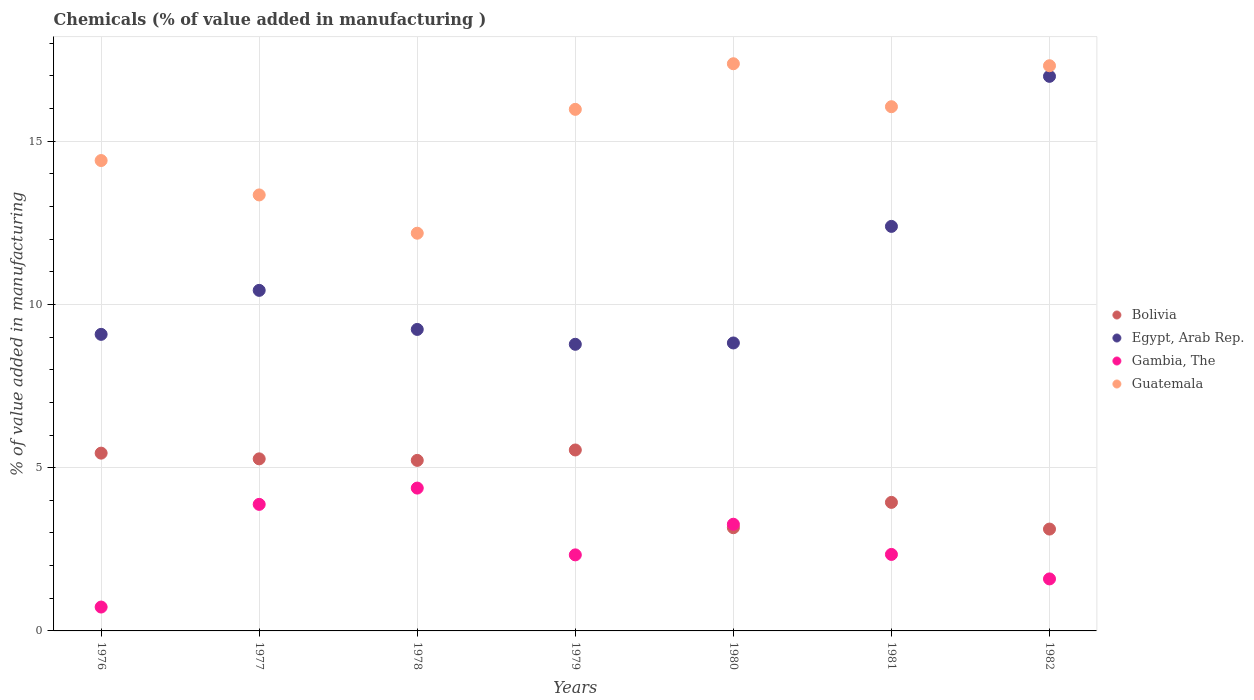Is the number of dotlines equal to the number of legend labels?
Your answer should be very brief. Yes. What is the value added in manufacturing chemicals in Bolivia in 1980?
Ensure brevity in your answer.  3.16. Across all years, what is the maximum value added in manufacturing chemicals in Gambia, The?
Offer a terse response. 4.38. Across all years, what is the minimum value added in manufacturing chemicals in Bolivia?
Your answer should be very brief. 3.12. In which year was the value added in manufacturing chemicals in Egypt, Arab Rep. minimum?
Ensure brevity in your answer.  1979. What is the total value added in manufacturing chemicals in Egypt, Arab Rep. in the graph?
Give a very brief answer. 75.73. What is the difference between the value added in manufacturing chemicals in Egypt, Arab Rep. in 1976 and that in 1982?
Provide a succinct answer. -7.9. What is the difference between the value added in manufacturing chemicals in Guatemala in 1976 and the value added in manufacturing chemicals in Bolivia in 1982?
Offer a very short reply. 11.29. What is the average value added in manufacturing chemicals in Gambia, The per year?
Offer a very short reply. 2.65. In the year 1979, what is the difference between the value added in manufacturing chemicals in Guatemala and value added in manufacturing chemicals in Bolivia?
Offer a very short reply. 10.43. In how many years, is the value added in manufacturing chemicals in Egypt, Arab Rep. greater than 6 %?
Offer a very short reply. 7. What is the ratio of the value added in manufacturing chemicals in Guatemala in 1979 to that in 1980?
Provide a succinct answer. 0.92. Is the value added in manufacturing chemicals in Guatemala in 1979 less than that in 1982?
Offer a terse response. Yes. What is the difference between the highest and the second highest value added in manufacturing chemicals in Guatemala?
Give a very brief answer. 0.06. What is the difference between the highest and the lowest value added in manufacturing chemicals in Bolivia?
Ensure brevity in your answer.  2.42. In how many years, is the value added in manufacturing chemicals in Egypt, Arab Rep. greater than the average value added in manufacturing chemicals in Egypt, Arab Rep. taken over all years?
Ensure brevity in your answer.  2. Is it the case that in every year, the sum of the value added in manufacturing chemicals in Guatemala and value added in manufacturing chemicals in Egypt, Arab Rep.  is greater than the sum of value added in manufacturing chemicals in Bolivia and value added in manufacturing chemicals in Gambia, The?
Give a very brief answer. Yes. Is it the case that in every year, the sum of the value added in manufacturing chemicals in Guatemala and value added in manufacturing chemicals in Bolivia  is greater than the value added in manufacturing chemicals in Gambia, The?
Provide a succinct answer. Yes. Does the value added in manufacturing chemicals in Bolivia monotonically increase over the years?
Your answer should be compact. No. Is the value added in manufacturing chemicals in Egypt, Arab Rep. strictly greater than the value added in manufacturing chemicals in Bolivia over the years?
Provide a succinct answer. Yes. Is the value added in manufacturing chemicals in Guatemala strictly less than the value added in manufacturing chemicals in Gambia, The over the years?
Ensure brevity in your answer.  No. How many years are there in the graph?
Your response must be concise. 7. What is the difference between two consecutive major ticks on the Y-axis?
Your answer should be compact. 5. Does the graph contain grids?
Offer a very short reply. Yes. How many legend labels are there?
Your response must be concise. 4. How are the legend labels stacked?
Give a very brief answer. Vertical. What is the title of the graph?
Make the answer very short. Chemicals (% of value added in manufacturing ). Does "Cyprus" appear as one of the legend labels in the graph?
Keep it short and to the point. No. What is the label or title of the X-axis?
Offer a terse response. Years. What is the label or title of the Y-axis?
Give a very brief answer. % of value added in manufacturing. What is the % of value added in manufacturing in Bolivia in 1976?
Your answer should be very brief. 5.45. What is the % of value added in manufacturing of Egypt, Arab Rep. in 1976?
Keep it short and to the point. 9.08. What is the % of value added in manufacturing in Gambia, The in 1976?
Your answer should be very brief. 0.73. What is the % of value added in manufacturing in Guatemala in 1976?
Make the answer very short. 14.41. What is the % of value added in manufacturing of Bolivia in 1977?
Provide a short and direct response. 5.27. What is the % of value added in manufacturing of Egypt, Arab Rep. in 1977?
Your answer should be compact. 10.43. What is the % of value added in manufacturing of Gambia, The in 1977?
Your response must be concise. 3.88. What is the % of value added in manufacturing of Guatemala in 1977?
Provide a succinct answer. 13.36. What is the % of value added in manufacturing of Bolivia in 1978?
Keep it short and to the point. 5.22. What is the % of value added in manufacturing in Egypt, Arab Rep. in 1978?
Provide a succinct answer. 9.24. What is the % of value added in manufacturing in Gambia, The in 1978?
Provide a short and direct response. 4.38. What is the % of value added in manufacturing of Guatemala in 1978?
Your response must be concise. 12.18. What is the % of value added in manufacturing in Bolivia in 1979?
Make the answer very short. 5.54. What is the % of value added in manufacturing in Egypt, Arab Rep. in 1979?
Ensure brevity in your answer.  8.78. What is the % of value added in manufacturing of Gambia, The in 1979?
Ensure brevity in your answer.  2.33. What is the % of value added in manufacturing in Guatemala in 1979?
Offer a very short reply. 15.98. What is the % of value added in manufacturing in Bolivia in 1980?
Your response must be concise. 3.16. What is the % of value added in manufacturing of Egypt, Arab Rep. in 1980?
Provide a short and direct response. 8.82. What is the % of value added in manufacturing in Gambia, The in 1980?
Provide a succinct answer. 3.27. What is the % of value added in manufacturing in Guatemala in 1980?
Make the answer very short. 17.37. What is the % of value added in manufacturing in Bolivia in 1981?
Make the answer very short. 3.94. What is the % of value added in manufacturing in Egypt, Arab Rep. in 1981?
Provide a short and direct response. 12.39. What is the % of value added in manufacturing of Gambia, The in 1981?
Your answer should be very brief. 2.34. What is the % of value added in manufacturing in Guatemala in 1981?
Provide a succinct answer. 16.06. What is the % of value added in manufacturing in Bolivia in 1982?
Your response must be concise. 3.12. What is the % of value added in manufacturing of Egypt, Arab Rep. in 1982?
Your response must be concise. 16.99. What is the % of value added in manufacturing in Gambia, The in 1982?
Make the answer very short. 1.59. What is the % of value added in manufacturing of Guatemala in 1982?
Keep it short and to the point. 17.31. Across all years, what is the maximum % of value added in manufacturing of Bolivia?
Your answer should be very brief. 5.54. Across all years, what is the maximum % of value added in manufacturing of Egypt, Arab Rep.?
Ensure brevity in your answer.  16.99. Across all years, what is the maximum % of value added in manufacturing in Gambia, The?
Offer a very short reply. 4.38. Across all years, what is the maximum % of value added in manufacturing of Guatemala?
Keep it short and to the point. 17.37. Across all years, what is the minimum % of value added in manufacturing of Bolivia?
Provide a succinct answer. 3.12. Across all years, what is the minimum % of value added in manufacturing in Egypt, Arab Rep.?
Provide a succinct answer. 8.78. Across all years, what is the minimum % of value added in manufacturing in Gambia, The?
Provide a succinct answer. 0.73. Across all years, what is the minimum % of value added in manufacturing of Guatemala?
Make the answer very short. 12.18. What is the total % of value added in manufacturing in Bolivia in the graph?
Your answer should be very brief. 31.7. What is the total % of value added in manufacturing of Egypt, Arab Rep. in the graph?
Your answer should be compact. 75.73. What is the total % of value added in manufacturing in Gambia, The in the graph?
Your answer should be compact. 18.52. What is the total % of value added in manufacturing of Guatemala in the graph?
Your answer should be compact. 106.67. What is the difference between the % of value added in manufacturing in Bolivia in 1976 and that in 1977?
Keep it short and to the point. 0.17. What is the difference between the % of value added in manufacturing in Egypt, Arab Rep. in 1976 and that in 1977?
Your answer should be compact. -1.35. What is the difference between the % of value added in manufacturing in Gambia, The in 1976 and that in 1977?
Your answer should be very brief. -3.15. What is the difference between the % of value added in manufacturing in Guatemala in 1976 and that in 1977?
Give a very brief answer. 1.05. What is the difference between the % of value added in manufacturing in Bolivia in 1976 and that in 1978?
Make the answer very short. 0.22. What is the difference between the % of value added in manufacturing in Egypt, Arab Rep. in 1976 and that in 1978?
Your answer should be very brief. -0.15. What is the difference between the % of value added in manufacturing in Gambia, The in 1976 and that in 1978?
Offer a very short reply. -3.64. What is the difference between the % of value added in manufacturing of Guatemala in 1976 and that in 1978?
Offer a very short reply. 2.23. What is the difference between the % of value added in manufacturing of Bolivia in 1976 and that in 1979?
Ensure brevity in your answer.  -0.1. What is the difference between the % of value added in manufacturing in Egypt, Arab Rep. in 1976 and that in 1979?
Provide a succinct answer. 0.3. What is the difference between the % of value added in manufacturing in Gambia, The in 1976 and that in 1979?
Provide a succinct answer. -1.6. What is the difference between the % of value added in manufacturing in Guatemala in 1976 and that in 1979?
Provide a succinct answer. -1.57. What is the difference between the % of value added in manufacturing in Bolivia in 1976 and that in 1980?
Provide a succinct answer. 2.28. What is the difference between the % of value added in manufacturing of Egypt, Arab Rep. in 1976 and that in 1980?
Your response must be concise. 0.26. What is the difference between the % of value added in manufacturing of Gambia, The in 1976 and that in 1980?
Your answer should be compact. -2.54. What is the difference between the % of value added in manufacturing in Guatemala in 1976 and that in 1980?
Ensure brevity in your answer.  -2.97. What is the difference between the % of value added in manufacturing of Bolivia in 1976 and that in 1981?
Keep it short and to the point. 1.51. What is the difference between the % of value added in manufacturing of Egypt, Arab Rep. in 1976 and that in 1981?
Provide a succinct answer. -3.31. What is the difference between the % of value added in manufacturing in Gambia, The in 1976 and that in 1981?
Provide a succinct answer. -1.61. What is the difference between the % of value added in manufacturing of Guatemala in 1976 and that in 1981?
Make the answer very short. -1.65. What is the difference between the % of value added in manufacturing in Bolivia in 1976 and that in 1982?
Offer a very short reply. 2.33. What is the difference between the % of value added in manufacturing of Egypt, Arab Rep. in 1976 and that in 1982?
Your response must be concise. -7.9. What is the difference between the % of value added in manufacturing of Gambia, The in 1976 and that in 1982?
Make the answer very short. -0.86. What is the difference between the % of value added in manufacturing of Guatemala in 1976 and that in 1982?
Offer a terse response. -2.9. What is the difference between the % of value added in manufacturing in Bolivia in 1977 and that in 1978?
Your answer should be very brief. 0.05. What is the difference between the % of value added in manufacturing of Egypt, Arab Rep. in 1977 and that in 1978?
Provide a succinct answer. 1.2. What is the difference between the % of value added in manufacturing in Gambia, The in 1977 and that in 1978?
Your answer should be compact. -0.5. What is the difference between the % of value added in manufacturing of Guatemala in 1977 and that in 1978?
Offer a very short reply. 1.17. What is the difference between the % of value added in manufacturing in Bolivia in 1977 and that in 1979?
Your answer should be compact. -0.27. What is the difference between the % of value added in manufacturing of Egypt, Arab Rep. in 1977 and that in 1979?
Offer a very short reply. 1.65. What is the difference between the % of value added in manufacturing of Gambia, The in 1977 and that in 1979?
Keep it short and to the point. 1.55. What is the difference between the % of value added in manufacturing in Guatemala in 1977 and that in 1979?
Give a very brief answer. -2.62. What is the difference between the % of value added in manufacturing in Bolivia in 1977 and that in 1980?
Provide a short and direct response. 2.11. What is the difference between the % of value added in manufacturing in Egypt, Arab Rep. in 1977 and that in 1980?
Give a very brief answer. 1.61. What is the difference between the % of value added in manufacturing in Gambia, The in 1977 and that in 1980?
Provide a short and direct response. 0.61. What is the difference between the % of value added in manufacturing of Guatemala in 1977 and that in 1980?
Offer a terse response. -4.02. What is the difference between the % of value added in manufacturing of Bolivia in 1977 and that in 1981?
Offer a very short reply. 1.33. What is the difference between the % of value added in manufacturing in Egypt, Arab Rep. in 1977 and that in 1981?
Ensure brevity in your answer.  -1.96. What is the difference between the % of value added in manufacturing in Gambia, The in 1977 and that in 1981?
Your answer should be compact. 1.53. What is the difference between the % of value added in manufacturing in Guatemala in 1977 and that in 1981?
Keep it short and to the point. -2.7. What is the difference between the % of value added in manufacturing in Bolivia in 1977 and that in 1982?
Your response must be concise. 2.15. What is the difference between the % of value added in manufacturing of Egypt, Arab Rep. in 1977 and that in 1982?
Provide a short and direct response. -6.56. What is the difference between the % of value added in manufacturing of Gambia, The in 1977 and that in 1982?
Your response must be concise. 2.28. What is the difference between the % of value added in manufacturing of Guatemala in 1977 and that in 1982?
Your response must be concise. -3.96. What is the difference between the % of value added in manufacturing of Bolivia in 1978 and that in 1979?
Provide a short and direct response. -0.32. What is the difference between the % of value added in manufacturing in Egypt, Arab Rep. in 1978 and that in 1979?
Your response must be concise. 0.46. What is the difference between the % of value added in manufacturing in Gambia, The in 1978 and that in 1979?
Make the answer very short. 2.05. What is the difference between the % of value added in manufacturing in Guatemala in 1978 and that in 1979?
Ensure brevity in your answer.  -3.79. What is the difference between the % of value added in manufacturing of Bolivia in 1978 and that in 1980?
Offer a terse response. 2.06. What is the difference between the % of value added in manufacturing of Egypt, Arab Rep. in 1978 and that in 1980?
Make the answer very short. 0.41. What is the difference between the % of value added in manufacturing of Gambia, The in 1978 and that in 1980?
Your response must be concise. 1.11. What is the difference between the % of value added in manufacturing in Guatemala in 1978 and that in 1980?
Provide a succinct answer. -5.19. What is the difference between the % of value added in manufacturing in Bolivia in 1978 and that in 1981?
Offer a terse response. 1.29. What is the difference between the % of value added in manufacturing of Egypt, Arab Rep. in 1978 and that in 1981?
Provide a short and direct response. -3.16. What is the difference between the % of value added in manufacturing of Gambia, The in 1978 and that in 1981?
Ensure brevity in your answer.  2.03. What is the difference between the % of value added in manufacturing of Guatemala in 1978 and that in 1981?
Provide a short and direct response. -3.88. What is the difference between the % of value added in manufacturing of Bolivia in 1978 and that in 1982?
Offer a terse response. 2.1. What is the difference between the % of value added in manufacturing of Egypt, Arab Rep. in 1978 and that in 1982?
Ensure brevity in your answer.  -7.75. What is the difference between the % of value added in manufacturing in Gambia, The in 1978 and that in 1982?
Your answer should be very brief. 2.78. What is the difference between the % of value added in manufacturing in Guatemala in 1978 and that in 1982?
Provide a short and direct response. -5.13. What is the difference between the % of value added in manufacturing in Bolivia in 1979 and that in 1980?
Offer a very short reply. 2.38. What is the difference between the % of value added in manufacturing in Egypt, Arab Rep. in 1979 and that in 1980?
Offer a very short reply. -0.04. What is the difference between the % of value added in manufacturing of Gambia, The in 1979 and that in 1980?
Offer a very short reply. -0.94. What is the difference between the % of value added in manufacturing of Guatemala in 1979 and that in 1980?
Ensure brevity in your answer.  -1.4. What is the difference between the % of value added in manufacturing of Bolivia in 1979 and that in 1981?
Offer a very short reply. 1.61. What is the difference between the % of value added in manufacturing in Egypt, Arab Rep. in 1979 and that in 1981?
Provide a short and direct response. -3.61. What is the difference between the % of value added in manufacturing in Gambia, The in 1979 and that in 1981?
Keep it short and to the point. -0.01. What is the difference between the % of value added in manufacturing of Guatemala in 1979 and that in 1981?
Ensure brevity in your answer.  -0.08. What is the difference between the % of value added in manufacturing in Bolivia in 1979 and that in 1982?
Give a very brief answer. 2.42. What is the difference between the % of value added in manufacturing of Egypt, Arab Rep. in 1979 and that in 1982?
Keep it short and to the point. -8.21. What is the difference between the % of value added in manufacturing of Gambia, The in 1979 and that in 1982?
Offer a terse response. 0.74. What is the difference between the % of value added in manufacturing of Guatemala in 1979 and that in 1982?
Offer a very short reply. -1.34. What is the difference between the % of value added in manufacturing of Bolivia in 1980 and that in 1981?
Your response must be concise. -0.78. What is the difference between the % of value added in manufacturing of Egypt, Arab Rep. in 1980 and that in 1981?
Provide a succinct answer. -3.57. What is the difference between the % of value added in manufacturing of Gambia, The in 1980 and that in 1981?
Offer a very short reply. 0.92. What is the difference between the % of value added in manufacturing in Guatemala in 1980 and that in 1981?
Ensure brevity in your answer.  1.32. What is the difference between the % of value added in manufacturing in Bolivia in 1980 and that in 1982?
Your answer should be very brief. 0.04. What is the difference between the % of value added in manufacturing of Egypt, Arab Rep. in 1980 and that in 1982?
Keep it short and to the point. -8.17. What is the difference between the % of value added in manufacturing of Gambia, The in 1980 and that in 1982?
Your answer should be compact. 1.67. What is the difference between the % of value added in manufacturing of Guatemala in 1980 and that in 1982?
Provide a succinct answer. 0.06. What is the difference between the % of value added in manufacturing of Bolivia in 1981 and that in 1982?
Offer a terse response. 0.82. What is the difference between the % of value added in manufacturing of Egypt, Arab Rep. in 1981 and that in 1982?
Make the answer very short. -4.6. What is the difference between the % of value added in manufacturing in Guatemala in 1981 and that in 1982?
Give a very brief answer. -1.25. What is the difference between the % of value added in manufacturing of Bolivia in 1976 and the % of value added in manufacturing of Egypt, Arab Rep. in 1977?
Make the answer very short. -4.99. What is the difference between the % of value added in manufacturing of Bolivia in 1976 and the % of value added in manufacturing of Gambia, The in 1977?
Offer a very short reply. 1.57. What is the difference between the % of value added in manufacturing in Bolivia in 1976 and the % of value added in manufacturing in Guatemala in 1977?
Make the answer very short. -7.91. What is the difference between the % of value added in manufacturing in Egypt, Arab Rep. in 1976 and the % of value added in manufacturing in Gambia, The in 1977?
Keep it short and to the point. 5.21. What is the difference between the % of value added in manufacturing in Egypt, Arab Rep. in 1976 and the % of value added in manufacturing in Guatemala in 1977?
Offer a terse response. -4.27. What is the difference between the % of value added in manufacturing of Gambia, The in 1976 and the % of value added in manufacturing of Guatemala in 1977?
Ensure brevity in your answer.  -12.62. What is the difference between the % of value added in manufacturing of Bolivia in 1976 and the % of value added in manufacturing of Egypt, Arab Rep. in 1978?
Offer a terse response. -3.79. What is the difference between the % of value added in manufacturing of Bolivia in 1976 and the % of value added in manufacturing of Gambia, The in 1978?
Your answer should be compact. 1.07. What is the difference between the % of value added in manufacturing in Bolivia in 1976 and the % of value added in manufacturing in Guatemala in 1978?
Keep it short and to the point. -6.74. What is the difference between the % of value added in manufacturing of Egypt, Arab Rep. in 1976 and the % of value added in manufacturing of Gambia, The in 1978?
Provide a short and direct response. 4.71. What is the difference between the % of value added in manufacturing of Egypt, Arab Rep. in 1976 and the % of value added in manufacturing of Guatemala in 1978?
Provide a succinct answer. -3.1. What is the difference between the % of value added in manufacturing in Gambia, The in 1976 and the % of value added in manufacturing in Guatemala in 1978?
Your answer should be compact. -11.45. What is the difference between the % of value added in manufacturing in Bolivia in 1976 and the % of value added in manufacturing in Egypt, Arab Rep. in 1979?
Offer a very short reply. -3.33. What is the difference between the % of value added in manufacturing in Bolivia in 1976 and the % of value added in manufacturing in Gambia, The in 1979?
Make the answer very short. 3.12. What is the difference between the % of value added in manufacturing of Bolivia in 1976 and the % of value added in manufacturing of Guatemala in 1979?
Provide a succinct answer. -10.53. What is the difference between the % of value added in manufacturing of Egypt, Arab Rep. in 1976 and the % of value added in manufacturing of Gambia, The in 1979?
Your answer should be compact. 6.75. What is the difference between the % of value added in manufacturing of Egypt, Arab Rep. in 1976 and the % of value added in manufacturing of Guatemala in 1979?
Give a very brief answer. -6.89. What is the difference between the % of value added in manufacturing in Gambia, The in 1976 and the % of value added in manufacturing in Guatemala in 1979?
Your response must be concise. -15.25. What is the difference between the % of value added in manufacturing of Bolivia in 1976 and the % of value added in manufacturing of Egypt, Arab Rep. in 1980?
Offer a very short reply. -3.38. What is the difference between the % of value added in manufacturing of Bolivia in 1976 and the % of value added in manufacturing of Gambia, The in 1980?
Provide a succinct answer. 2.18. What is the difference between the % of value added in manufacturing of Bolivia in 1976 and the % of value added in manufacturing of Guatemala in 1980?
Provide a short and direct response. -11.93. What is the difference between the % of value added in manufacturing of Egypt, Arab Rep. in 1976 and the % of value added in manufacturing of Gambia, The in 1980?
Your answer should be compact. 5.82. What is the difference between the % of value added in manufacturing of Egypt, Arab Rep. in 1976 and the % of value added in manufacturing of Guatemala in 1980?
Ensure brevity in your answer.  -8.29. What is the difference between the % of value added in manufacturing of Gambia, The in 1976 and the % of value added in manufacturing of Guatemala in 1980?
Your answer should be compact. -16.64. What is the difference between the % of value added in manufacturing of Bolivia in 1976 and the % of value added in manufacturing of Egypt, Arab Rep. in 1981?
Provide a short and direct response. -6.95. What is the difference between the % of value added in manufacturing of Bolivia in 1976 and the % of value added in manufacturing of Gambia, The in 1981?
Your response must be concise. 3.1. What is the difference between the % of value added in manufacturing of Bolivia in 1976 and the % of value added in manufacturing of Guatemala in 1981?
Keep it short and to the point. -10.61. What is the difference between the % of value added in manufacturing in Egypt, Arab Rep. in 1976 and the % of value added in manufacturing in Gambia, The in 1981?
Provide a succinct answer. 6.74. What is the difference between the % of value added in manufacturing of Egypt, Arab Rep. in 1976 and the % of value added in manufacturing of Guatemala in 1981?
Offer a very short reply. -6.97. What is the difference between the % of value added in manufacturing of Gambia, The in 1976 and the % of value added in manufacturing of Guatemala in 1981?
Ensure brevity in your answer.  -15.33. What is the difference between the % of value added in manufacturing in Bolivia in 1976 and the % of value added in manufacturing in Egypt, Arab Rep. in 1982?
Provide a short and direct response. -11.54. What is the difference between the % of value added in manufacturing in Bolivia in 1976 and the % of value added in manufacturing in Gambia, The in 1982?
Keep it short and to the point. 3.85. What is the difference between the % of value added in manufacturing of Bolivia in 1976 and the % of value added in manufacturing of Guatemala in 1982?
Your answer should be compact. -11.87. What is the difference between the % of value added in manufacturing in Egypt, Arab Rep. in 1976 and the % of value added in manufacturing in Gambia, The in 1982?
Give a very brief answer. 7.49. What is the difference between the % of value added in manufacturing in Egypt, Arab Rep. in 1976 and the % of value added in manufacturing in Guatemala in 1982?
Make the answer very short. -8.23. What is the difference between the % of value added in manufacturing in Gambia, The in 1976 and the % of value added in manufacturing in Guatemala in 1982?
Keep it short and to the point. -16.58. What is the difference between the % of value added in manufacturing of Bolivia in 1977 and the % of value added in manufacturing of Egypt, Arab Rep. in 1978?
Ensure brevity in your answer.  -3.96. What is the difference between the % of value added in manufacturing in Bolivia in 1977 and the % of value added in manufacturing in Gambia, The in 1978?
Keep it short and to the point. 0.9. What is the difference between the % of value added in manufacturing of Bolivia in 1977 and the % of value added in manufacturing of Guatemala in 1978?
Make the answer very short. -6.91. What is the difference between the % of value added in manufacturing in Egypt, Arab Rep. in 1977 and the % of value added in manufacturing in Gambia, The in 1978?
Provide a short and direct response. 6.06. What is the difference between the % of value added in manufacturing of Egypt, Arab Rep. in 1977 and the % of value added in manufacturing of Guatemala in 1978?
Offer a terse response. -1.75. What is the difference between the % of value added in manufacturing of Gambia, The in 1977 and the % of value added in manufacturing of Guatemala in 1978?
Provide a short and direct response. -8.31. What is the difference between the % of value added in manufacturing of Bolivia in 1977 and the % of value added in manufacturing of Egypt, Arab Rep. in 1979?
Your answer should be compact. -3.51. What is the difference between the % of value added in manufacturing of Bolivia in 1977 and the % of value added in manufacturing of Gambia, The in 1979?
Your answer should be very brief. 2.94. What is the difference between the % of value added in manufacturing in Bolivia in 1977 and the % of value added in manufacturing in Guatemala in 1979?
Make the answer very short. -10.71. What is the difference between the % of value added in manufacturing in Egypt, Arab Rep. in 1977 and the % of value added in manufacturing in Gambia, The in 1979?
Offer a very short reply. 8.1. What is the difference between the % of value added in manufacturing of Egypt, Arab Rep. in 1977 and the % of value added in manufacturing of Guatemala in 1979?
Provide a succinct answer. -5.54. What is the difference between the % of value added in manufacturing of Gambia, The in 1977 and the % of value added in manufacturing of Guatemala in 1979?
Keep it short and to the point. -12.1. What is the difference between the % of value added in manufacturing in Bolivia in 1977 and the % of value added in manufacturing in Egypt, Arab Rep. in 1980?
Make the answer very short. -3.55. What is the difference between the % of value added in manufacturing of Bolivia in 1977 and the % of value added in manufacturing of Gambia, The in 1980?
Give a very brief answer. 2. What is the difference between the % of value added in manufacturing of Bolivia in 1977 and the % of value added in manufacturing of Guatemala in 1980?
Give a very brief answer. -12.1. What is the difference between the % of value added in manufacturing in Egypt, Arab Rep. in 1977 and the % of value added in manufacturing in Gambia, The in 1980?
Ensure brevity in your answer.  7.16. What is the difference between the % of value added in manufacturing of Egypt, Arab Rep. in 1977 and the % of value added in manufacturing of Guatemala in 1980?
Ensure brevity in your answer.  -6.94. What is the difference between the % of value added in manufacturing of Gambia, The in 1977 and the % of value added in manufacturing of Guatemala in 1980?
Keep it short and to the point. -13.5. What is the difference between the % of value added in manufacturing of Bolivia in 1977 and the % of value added in manufacturing of Egypt, Arab Rep. in 1981?
Offer a terse response. -7.12. What is the difference between the % of value added in manufacturing in Bolivia in 1977 and the % of value added in manufacturing in Gambia, The in 1981?
Offer a very short reply. 2.93. What is the difference between the % of value added in manufacturing in Bolivia in 1977 and the % of value added in manufacturing in Guatemala in 1981?
Ensure brevity in your answer.  -10.79. What is the difference between the % of value added in manufacturing of Egypt, Arab Rep. in 1977 and the % of value added in manufacturing of Gambia, The in 1981?
Your answer should be compact. 8.09. What is the difference between the % of value added in manufacturing of Egypt, Arab Rep. in 1977 and the % of value added in manufacturing of Guatemala in 1981?
Your answer should be very brief. -5.63. What is the difference between the % of value added in manufacturing of Gambia, The in 1977 and the % of value added in manufacturing of Guatemala in 1981?
Offer a terse response. -12.18. What is the difference between the % of value added in manufacturing of Bolivia in 1977 and the % of value added in manufacturing of Egypt, Arab Rep. in 1982?
Offer a very short reply. -11.72. What is the difference between the % of value added in manufacturing in Bolivia in 1977 and the % of value added in manufacturing in Gambia, The in 1982?
Your answer should be very brief. 3.68. What is the difference between the % of value added in manufacturing of Bolivia in 1977 and the % of value added in manufacturing of Guatemala in 1982?
Offer a terse response. -12.04. What is the difference between the % of value added in manufacturing in Egypt, Arab Rep. in 1977 and the % of value added in manufacturing in Gambia, The in 1982?
Offer a very short reply. 8.84. What is the difference between the % of value added in manufacturing of Egypt, Arab Rep. in 1977 and the % of value added in manufacturing of Guatemala in 1982?
Your response must be concise. -6.88. What is the difference between the % of value added in manufacturing of Gambia, The in 1977 and the % of value added in manufacturing of Guatemala in 1982?
Provide a succinct answer. -13.44. What is the difference between the % of value added in manufacturing in Bolivia in 1978 and the % of value added in manufacturing in Egypt, Arab Rep. in 1979?
Provide a short and direct response. -3.56. What is the difference between the % of value added in manufacturing of Bolivia in 1978 and the % of value added in manufacturing of Gambia, The in 1979?
Provide a succinct answer. 2.89. What is the difference between the % of value added in manufacturing in Bolivia in 1978 and the % of value added in manufacturing in Guatemala in 1979?
Provide a succinct answer. -10.75. What is the difference between the % of value added in manufacturing of Egypt, Arab Rep. in 1978 and the % of value added in manufacturing of Gambia, The in 1979?
Make the answer very short. 6.91. What is the difference between the % of value added in manufacturing of Egypt, Arab Rep. in 1978 and the % of value added in manufacturing of Guatemala in 1979?
Provide a succinct answer. -6.74. What is the difference between the % of value added in manufacturing in Gambia, The in 1978 and the % of value added in manufacturing in Guatemala in 1979?
Make the answer very short. -11.6. What is the difference between the % of value added in manufacturing of Bolivia in 1978 and the % of value added in manufacturing of Egypt, Arab Rep. in 1980?
Your answer should be very brief. -3.6. What is the difference between the % of value added in manufacturing of Bolivia in 1978 and the % of value added in manufacturing of Gambia, The in 1980?
Give a very brief answer. 1.96. What is the difference between the % of value added in manufacturing in Bolivia in 1978 and the % of value added in manufacturing in Guatemala in 1980?
Your response must be concise. -12.15. What is the difference between the % of value added in manufacturing in Egypt, Arab Rep. in 1978 and the % of value added in manufacturing in Gambia, The in 1980?
Provide a succinct answer. 5.97. What is the difference between the % of value added in manufacturing in Egypt, Arab Rep. in 1978 and the % of value added in manufacturing in Guatemala in 1980?
Give a very brief answer. -8.14. What is the difference between the % of value added in manufacturing of Gambia, The in 1978 and the % of value added in manufacturing of Guatemala in 1980?
Offer a very short reply. -13. What is the difference between the % of value added in manufacturing in Bolivia in 1978 and the % of value added in manufacturing in Egypt, Arab Rep. in 1981?
Keep it short and to the point. -7.17. What is the difference between the % of value added in manufacturing in Bolivia in 1978 and the % of value added in manufacturing in Gambia, The in 1981?
Offer a very short reply. 2.88. What is the difference between the % of value added in manufacturing of Bolivia in 1978 and the % of value added in manufacturing of Guatemala in 1981?
Give a very brief answer. -10.83. What is the difference between the % of value added in manufacturing of Egypt, Arab Rep. in 1978 and the % of value added in manufacturing of Gambia, The in 1981?
Offer a very short reply. 6.89. What is the difference between the % of value added in manufacturing of Egypt, Arab Rep. in 1978 and the % of value added in manufacturing of Guatemala in 1981?
Offer a very short reply. -6.82. What is the difference between the % of value added in manufacturing in Gambia, The in 1978 and the % of value added in manufacturing in Guatemala in 1981?
Offer a terse response. -11.68. What is the difference between the % of value added in manufacturing in Bolivia in 1978 and the % of value added in manufacturing in Egypt, Arab Rep. in 1982?
Your answer should be compact. -11.76. What is the difference between the % of value added in manufacturing of Bolivia in 1978 and the % of value added in manufacturing of Gambia, The in 1982?
Offer a very short reply. 3.63. What is the difference between the % of value added in manufacturing in Bolivia in 1978 and the % of value added in manufacturing in Guatemala in 1982?
Make the answer very short. -12.09. What is the difference between the % of value added in manufacturing of Egypt, Arab Rep. in 1978 and the % of value added in manufacturing of Gambia, The in 1982?
Ensure brevity in your answer.  7.64. What is the difference between the % of value added in manufacturing of Egypt, Arab Rep. in 1978 and the % of value added in manufacturing of Guatemala in 1982?
Provide a short and direct response. -8.08. What is the difference between the % of value added in manufacturing in Gambia, The in 1978 and the % of value added in manufacturing in Guatemala in 1982?
Your response must be concise. -12.94. What is the difference between the % of value added in manufacturing in Bolivia in 1979 and the % of value added in manufacturing in Egypt, Arab Rep. in 1980?
Your answer should be compact. -3.28. What is the difference between the % of value added in manufacturing of Bolivia in 1979 and the % of value added in manufacturing of Gambia, The in 1980?
Keep it short and to the point. 2.27. What is the difference between the % of value added in manufacturing of Bolivia in 1979 and the % of value added in manufacturing of Guatemala in 1980?
Provide a succinct answer. -11.83. What is the difference between the % of value added in manufacturing of Egypt, Arab Rep. in 1979 and the % of value added in manufacturing of Gambia, The in 1980?
Keep it short and to the point. 5.51. What is the difference between the % of value added in manufacturing of Egypt, Arab Rep. in 1979 and the % of value added in manufacturing of Guatemala in 1980?
Keep it short and to the point. -8.59. What is the difference between the % of value added in manufacturing of Gambia, The in 1979 and the % of value added in manufacturing of Guatemala in 1980?
Offer a terse response. -15.04. What is the difference between the % of value added in manufacturing of Bolivia in 1979 and the % of value added in manufacturing of Egypt, Arab Rep. in 1981?
Provide a succinct answer. -6.85. What is the difference between the % of value added in manufacturing in Bolivia in 1979 and the % of value added in manufacturing in Gambia, The in 1981?
Your answer should be very brief. 3.2. What is the difference between the % of value added in manufacturing in Bolivia in 1979 and the % of value added in manufacturing in Guatemala in 1981?
Your response must be concise. -10.51. What is the difference between the % of value added in manufacturing of Egypt, Arab Rep. in 1979 and the % of value added in manufacturing of Gambia, The in 1981?
Ensure brevity in your answer.  6.44. What is the difference between the % of value added in manufacturing in Egypt, Arab Rep. in 1979 and the % of value added in manufacturing in Guatemala in 1981?
Provide a short and direct response. -7.28. What is the difference between the % of value added in manufacturing of Gambia, The in 1979 and the % of value added in manufacturing of Guatemala in 1981?
Provide a short and direct response. -13.73. What is the difference between the % of value added in manufacturing of Bolivia in 1979 and the % of value added in manufacturing of Egypt, Arab Rep. in 1982?
Your answer should be very brief. -11.45. What is the difference between the % of value added in manufacturing of Bolivia in 1979 and the % of value added in manufacturing of Gambia, The in 1982?
Give a very brief answer. 3.95. What is the difference between the % of value added in manufacturing in Bolivia in 1979 and the % of value added in manufacturing in Guatemala in 1982?
Keep it short and to the point. -11.77. What is the difference between the % of value added in manufacturing in Egypt, Arab Rep. in 1979 and the % of value added in manufacturing in Gambia, The in 1982?
Make the answer very short. 7.19. What is the difference between the % of value added in manufacturing of Egypt, Arab Rep. in 1979 and the % of value added in manufacturing of Guatemala in 1982?
Make the answer very short. -8.53. What is the difference between the % of value added in manufacturing of Gambia, The in 1979 and the % of value added in manufacturing of Guatemala in 1982?
Your answer should be very brief. -14.98. What is the difference between the % of value added in manufacturing in Bolivia in 1980 and the % of value added in manufacturing in Egypt, Arab Rep. in 1981?
Give a very brief answer. -9.23. What is the difference between the % of value added in manufacturing in Bolivia in 1980 and the % of value added in manufacturing in Gambia, The in 1981?
Your response must be concise. 0.82. What is the difference between the % of value added in manufacturing of Bolivia in 1980 and the % of value added in manufacturing of Guatemala in 1981?
Provide a succinct answer. -12.9. What is the difference between the % of value added in manufacturing of Egypt, Arab Rep. in 1980 and the % of value added in manufacturing of Gambia, The in 1981?
Your answer should be very brief. 6.48. What is the difference between the % of value added in manufacturing of Egypt, Arab Rep. in 1980 and the % of value added in manufacturing of Guatemala in 1981?
Make the answer very short. -7.24. What is the difference between the % of value added in manufacturing in Gambia, The in 1980 and the % of value added in manufacturing in Guatemala in 1981?
Make the answer very short. -12.79. What is the difference between the % of value added in manufacturing in Bolivia in 1980 and the % of value added in manufacturing in Egypt, Arab Rep. in 1982?
Make the answer very short. -13.83. What is the difference between the % of value added in manufacturing in Bolivia in 1980 and the % of value added in manufacturing in Gambia, The in 1982?
Offer a terse response. 1.57. What is the difference between the % of value added in manufacturing in Bolivia in 1980 and the % of value added in manufacturing in Guatemala in 1982?
Ensure brevity in your answer.  -14.15. What is the difference between the % of value added in manufacturing of Egypt, Arab Rep. in 1980 and the % of value added in manufacturing of Gambia, The in 1982?
Provide a succinct answer. 7.23. What is the difference between the % of value added in manufacturing of Egypt, Arab Rep. in 1980 and the % of value added in manufacturing of Guatemala in 1982?
Ensure brevity in your answer.  -8.49. What is the difference between the % of value added in manufacturing in Gambia, The in 1980 and the % of value added in manufacturing in Guatemala in 1982?
Offer a very short reply. -14.04. What is the difference between the % of value added in manufacturing in Bolivia in 1981 and the % of value added in manufacturing in Egypt, Arab Rep. in 1982?
Your response must be concise. -13.05. What is the difference between the % of value added in manufacturing of Bolivia in 1981 and the % of value added in manufacturing of Gambia, The in 1982?
Provide a short and direct response. 2.34. What is the difference between the % of value added in manufacturing of Bolivia in 1981 and the % of value added in manufacturing of Guatemala in 1982?
Provide a short and direct response. -13.38. What is the difference between the % of value added in manufacturing of Egypt, Arab Rep. in 1981 and the % of value added in manufacturing of Gambia, The in 1982?
Offer a terse response. 10.8. What is the difference between the % of value added in manufacturing of Egypt, Arab Rep. in 1981 and the % of value added in manufacturing of Guatemala in 1982?
Provide a succinct answer. -4.92. What is the difference between the % of value added in manufacturing of Gambia, The in 1981 and the % of value added in manufacturing of Guatemala in 1982?
Offer a terse response. -14.97. What is the average % of value added in manufacturing of Bolivia per year?
Your answer should be compact. 4.53. What is the average % of value added in manufacturing of Egypt, Arab Rep. per year?
Give a very brief answer. 10.82. What is the average % of value added in manufacturing in Gambia, The per year?
Offer a very short reply. 2.65. What is the average % of value added in manufacturing in Guatemala per year?
Provide a short and direct response. 15.24. In the year 1976, what is the difference between the % of value added in manufacturing in Bolivia and % of value added in manufacturing in Egypt, Arab Rep.?
Offer a terse response. -3.64. In the year 1976, what is the difference between the % of value added in manufacturing in Bolivia and % of value added in manufacturing in Gambia, The?
Your answer should be very brief. 4.71. In the year 1976, what is the difference between the % of value added in manufacturing in Bolivia and % of value added in manufacturing in Guatemala?
Provide a succinct answer. -8.96. In the year 1976, what is the difference between the % of value added in manufacturing in Egypt, Arab Rep. and % of value added in manufacturing in Gambia, The?
Make the answer very short. 8.35. In the year 1976, what is the difference between the % of value added in manufacturing of Egypt, Arab Rep. and % of value added in manufacturing of Guatemala?
Keep it short and to the point. -5.32. In the year 1976, what is the difference between the % of value added in manufacturing in Gambia, The and % of value added in manufacturing in Guatemala?
Offer a very short reply. -13.68. In the year 1977, what is the difference between the % of value added in manufacturing in Bolivia and % of value added in manufacturing in Egypt, Arab Rep.?
Make the answer very short. -5.16. In the year 1977, what is the difference between the % of value added in manufacturing in Bolivia and % of value added in manufacturing in Gambia, The?
Your answer should be compact. 1.39. In the year 1977, what is the difference between the % of value added in manufacturing in Bolivia and % of value added in manufacturing in Guatemala?
Offer a very short reply. -8.08. In the year 1977, what is the difference between the % of value added in manufacturing in Egypt, Arab Rep. and % of value added in manufacturing in Gambia, The?
Your answer should be compact. 6.56. In the year 1977, what is the difference between the % of value added in manufacturing in Egypt, Arab Rep. and % of value added in manufacturing in Guatemala?
Offer a terse response. -2.92. In the year 1977, what is the difference between the % of value added in manufacturing in Gambia, The and % of value added in manufacturing in Guatemala?
Offer a terse response. -9.48. In the year 1978, what is the difference between the % of value added in manufacturing in Bolivia and % of value added in manufacturing in Egypt, Arab Rep.?
Provide a succinct answer. -4.01. In the year 1978, what is the difference between the % of value added in manufacturing in Bolivia and % of value added in manufacturing in Gambia, The?
Make the answer very short. 0.85. In the year 1978, what is the difference between the % of value added in manufacturing of Bolivia and % of value added in manufacturing of Guatemala?
Ensure brevity in your answer.  -6.96. In the year 1978, what is the difference between the % of value added in manufacturing of Egypt, Arab Rep. and % of value added in manufacturing of Gambia, The?
Your answer should be very brief. 4.86. In the year 1978, what is the difference between the % of value added in manufacturing of Egypt, Arab Rep. and % of value added in manufacturing of Guatemala?
Your answer should be very brief. -2.95. In the year 1978, what is the difference between the % of value added in manufacturing in Gambia, The and % of value added in manufacturing in Guatemala?
Provide a short and direct response. -7.81. In the year 1979, what is the difference between the % of value added in manufacturing in Bolivia and % of value added in manufacturing in Egypt, Arab Rep.?
Keep it short and to the point. -3.24. In the year 1979, what is the difference between the % of value added in manufacturing in Bolivia and % of value added in manufacturing in Gambia, The?
Give a very brief answer. 3.21. In the year 1979, what is the difference between the % of value added in manufacturing of Bolivia and % of value added in manufacturing of Guatemala?
Your answer should be compact. -10.43. In the year 1979, what is the difference between the % of value added in manufacturing in Egypt, Arab Rep. and % of value added in manufacturing in Gambia, The?
Your answer should be very brief. 6.45. In the year 1979, what is the difference between the % of value added in manufacturing in Egypt, Arab Rep. and % of value added in manufacturing in Guatemala?
Keep it short and to the point. -7.2. In the year 1979, what is the difference between the % of value added in manufacturing in Gambia, The and % of value added in manufacturing in Guatemala?
Ensure brevity in your answer.  -13.65. In the year 1980, what is the difference between the % of value added in manufacturing in Bolivia and % of value added in manufacturing in Egypt, Arab Rep.?
Offer a terse response. -5.66. In the year 1980, what is the difference between the % of value added in manufacturing in Bolivia and % of value added in manufacturing in Gambia, The?
Ensure brevity in your answer.  -0.11. In the year 1980, what is the difference between the % of value added in manufacturing of Bolivia and % of value added in manufacturing of Guatemala?
Offer a terse response. -14.21. In the year 1980, what is the difference between the % of value added in manufacturing in Egypt, Arab Rep. and % of value added in manufacturing in Gambia, The?
Your answer should be compact. 5.55. In the year 1980, what is the difference between the % of value added in manufacturing in Egypt, Arab Rep. and % of value added in manufacturing in Guatemala?
Offer a very short reply. -8.55. In the year 1980, what is the difference between the % of value added in manufacturing in Gambia, The and % of value added in manufacturing in Guatemala?
Provide a succinct answer. -14.11. In the year 1981, what is the difference between the % of value added in manufacturing of Bolivia and % of value added in manufacturing of Egypt, Arab Rep.?
Offer a very short reply. -8.45. In the year 1981, what is the difference between the % of value added in manufacturing in Bolivia and % of value added in manufacturing in Gambia, The?
Offer a terse response. 1.59. In the year 1981, what is the difference between the % of value added in manufacturing in Bolivia and % of value added in manufacturing in Guatemala?
Your answer should be very brief. -12.12. In the year 1981, what is the difference between the % of value added in manufacturing in Egypt, Arab Rep. and % of value added in manufacturing in Gambia, The?
Your answer should be very brief. 10.05. In the year 1981, what is the difference between the % of value added in manufacturing of Egypt, Arab Rep. and % of value added in manufacturing of Guatemala?
Offer a terse response. -3.67. In the year 1981, what is the difference between the % of value added in manufacturing of Gambia, The and % of value added in manufacturing of Guatemala?
Provide a short and direct response. -13.71. In the year 1982, what is the difference between the % of value added in manufacturing of Bolivia and % of value added in manufacturing of Egypt, Arab Rep.?
Offer a very short reply. -13.87. In the year 1982, what is the difference between the % of value added in manufacturing of Bolivia and % of value added in manufacturing of Gambia, The?
Ensure brevity in your answer.  1.53. In the year 1982, what is the difference between the % of value added in manufacturing in Bolivia and % of value added in manufacturing in Guatemala?
Ensure brevity in your answer.  -14.19. In the year 1982, what is the difference between the % of value added in manufacturing in Egypt, Arab Rep. and % of value added in manufacturing in Gambia, The?
Keep it short and to the point. 15.39. In the year 1982, what is the difference between the % of value added in manufacturing in Egypt, Arab Rep. and % of value added in manufacturing in Guatemala?
Make the answer very short. -0.32. In the year 1982, what is the difference between the % of value added in manufacturing of Gambia, The and % of value added in manufacturing of Guatemala?
Make the answer very short. -15.72. What is the ratio of the % of value added in manufacturing of Bolivia in 1976 to that in 1977?
Offer a very short reply. 1.03. What is the ratio of the % of value added in manufacturing of Egypt, Arab Rep. in 1976 to that in 1977?
Ensure brevity in your answer.  0.87. What is the ratio of the % of value added in manufacturing in Gambia, The in 1976 to that in 1977?
Your answer should be compact. 0.19. What is the ratio of the % of value added in manufacturing in Guatemala in 1976 to that in 1977?
Provide a short and direct response. 1.08. What is the ratio of the % of value added in manufacturing of Bolivia in 1976 to that in 1978?
Give a very brief answer. 1.04. What is the ratio of the % of value added in manufacturing in Egypt, Arab Rep. in 1976 to that in 1978?
Your response must be concise. 0.98. What is the ratio of the % of value added in manufacturing of Gambia, The in 1976 to that in 1978?
Provide a short and direct response. 0.17. What is the ratio of the % of value added in manufacturing in Guatemala in 1976 to that in 1978?
Provide a succinct answer. 1.18. What is the ratio of the % of value added in manufacturing of Bolivia in 1976 to that in 1979?
Your answer should be very brief. 0.98. What is the ratio of the % of value added in manufacturing of Egypt, Arab Rep. in 1976 to that in 1979?
Your response must be concise. 1.03. What is the ratio of the % of value added in manufacturing in Gambia, The in 1976 to that in 1979?
Your answer should be very brief. 0.31. What is the ratio of the % of value added in manufacturing of Guatemala in 1976 to that in 1979?
Give a very brief answer. 0.9. What is the ratio of the % of value added in manufacturing of Bolivia in 1976 to that in 1980?
Your answer should be very brief. 1.72. What is the ratio of the % of value added in manufacturing of Egypt, Arab Rep. in 1976 to that in 1980?
Provide a short and direct response. 1.03. What is the ratio of the % of value added in manufacturing in Gambia, The in 1976 to that in 1980?
Offer a terse response. 0.22. What is the ratio of the % of value added in manufacturing of Guatemala in 1976 to that in 1980?
Provide a short and direct response. 0.83. What is the ratio of the % of value added in manufacturing in Bolivia in 1976 to that in 1981?
Your answer should be very brief. 1.38. What is the ratio of the % of value added in manufacturing in Egypt, Arab Rep. in 1976 to that in 1981?
Provide a succinct answer. 0.73. What is the ratio of the % of value added in manufacturing of Gambia, The in 1976 to that in 1981?
Provide a succinct answer. 0.31. What is the ratio of the % of value added in manufacturing of Guatemala in 1976 to that in 1981?
Your response must be concise. 0.9. What is the ratio of the % of value added in manufacturing in Bolivia in 1976 to that in 1982?
Keep it short and to the point. 1.75. What is the ratio of the % of value added in manufacturing in Egypt, Arab Rep. in 1976 to that in 1982?
Provide a short and direct response. 0.53. What is the ratio of the % of value added in manufacturing of Gambia, The in 1976 to that in 1982?
Offer a very short reply. 0.46. What is the ratio of the % of value added in manufacturing of Guatemala in 1976 to that in 1982?
Give a very brief answer. 0.83. What is the ratio of the % of value added in manufacturing of Egypt, Arab Rep. in 1977 to that in 1978?
Provide a short and direct response. 1.13. What is the ratio of the % of value added in manufacturing in Gambia, The in 1977 to that in 1978?
Ensure brevity in your answer.  0.89. What is the ratio of the % of value added in manufacturing of Guatemala in 1977 to that in 1978?
Provide a succinct answer. 1.1. What is the ratio of the % of value added in manufacturing in Bolivia in 1977 to that in 1979?
Give a very brief answer. 0.95. What is the ratio of the % of value added in manufacturing in Egypt, Arab Rep. in 1977 to that in 1979?
Offer a terse response. 1.19. What is the ratio of the % of value added in manufacturing of Gambia, The in 1977 to that in 1979?
Provide a short and direct response. 1.66. What is the ratio of the % of value added in manufacturing of Guatemala in 1977 to that in 1979?
Offer a very short reply. 0.84. What is the ratio of the % of value added in manufacturing of Bolivia in 1977 to that in 1980?
Keep it short and to the point. 1.67. What is the ratio of the % of value added in manufacturing of Egypt, Arab Rep. in 1977 to that in 1980?
Provide a short and direct response. 1.18. What is the ratio of the % of value added in manufacturing of Gambia, The in 1977 to that in 1980?
Keep it short and to the point. 1.19. What is the ratio of the % of value added in manufacturing in Guatemala in 1977 to that in 1980?
Give a very brief answer. 0.77. What is the ratio of the % of value added in manufacturing of Bolivia in 1977 to that in 1981?
Give a very brief answer. 1.34. What is the ratio of the % of value added in manufacturing of Egypt, Arab Rep. in 1977 to that in 1981?
Your answer should be very brief. 0.84. What is the ratio of the % of value added in manufacturing in Gambia, The in 1977 to that in 1981?
Provide a succinct answer. 1.65. What is the ratio of the % of value added in manufacturing of Guatemala in 1977 to that in 1981?
Offer a terse response. 0.83. What is the ratio of the % of value added in manufacturing of Bolivia in 1977 to that in 1982?
Your answer should be very brief. 1.69. What is the ratio of the % of value added in manufacturing of Egypt, Arab Rep. in 1977 to that in 1982?
Your answer should be compact. 0.61. What is the ratio of the % of value added in manufacturing of Gambia, The in 1977 to that in 1982?
Offer a very short reply. 2.43. What is the ratio of the % of value added in manufacturing of Guatemala in 1977 to that in 1982?
Keep it short and to the point. 0.77. What is the ratio of the % of value added in manufacturing of Bolivia in 1978 to that in 1979?
Your answer should be compact. 0.94. What is the ratio of the % of value added in manufacturing in Egypt, Arab Rep. in 1978 to that in 1979?
Keep it short and to the point. 1.05. What is the ratio of the % of value added in manufacturing of Gambia, The in 1978 to that in 1979?
Give a very brief answer. 1.88. What is the ratio of the % of value added in manufacturing of Guatemala in 1978 to that in 1979?
Your answer should be very brief. 0.76. What is the ratio of the % of value added in manufacturing in Bolivia in 1978 to that in 1980?
Make the answer very short. 1.65. What is the ratio of the % of value added in manufacturing in Egypt, Arab Rep. in 1978 to that in 1980?
Your response must be concise. 1.05. What is the ratio of the % of value added in manufacturing of Gambia, The in 1978 to that in 1980?
Provide a short and direct response. 1.34. What is the ratio of the % of value added in manufacturing of Guatemala in 1978 to that in 1980?
Your response must be concise. 0.7. What is the ratio of the % of value added in manufacturing of Bolivia in 1978 to that in 1981?
Keep it short and to the point. 1.33. What is the ratio of the % of value added in manufacturing in Egypt, Arab Rep. in 1978 to that in 1981?
Your answer should be very brief. 0.75. What is the ratio of the % of value added in manufacturing of Gambia, The in 1978 to that in 1981?
Make the answer very short. 1.87. What is the ratio of the % of value added in manufacturing of Guatemala in 1978 to that in 1981?
Your answer should be very brief. 0.76. What is the ratio of the % of value added in manufacturing of Bolivia in 1978 to that in 1982?
Ensure brevity in your answer.  1.67. What is the ratio of the % of value added in manufacturing in Egypt, Arab Rep. in 1978 to that in 1982?
Keep it short and to the point. 0.54. What is the ratio of the % of value added in manufacturing of Gambia, The in 1978 to that in 1982?
Give a very brief answer. 2.75. What is the ratio of the % of value added in manufacturing in Guatemala in 1978 to that in 1982?
Your answer should be very brief. 0.7. What is the ratio of the % of value added in manufacturing of Bolivia in 1979 to that in 1980?
Provide a short and direct response. 1.75. What is the ratio of the % of value added in manufacturing in Gambia, The in 1979 to that in 1980?
Provide a succinct answer. 0.71. What is the ratio of the % of value added in manufacturing in Guatemala in 1979 to that in 1980?
Offer a very short reply. 0.92. What is the ratio of the % of value added in manufacturing in Bolivia in 1979 to that in 1981?
Ensure brevity in your answer.  1.41. What is the ratio of the % of value added in manufacturing in Egypt, Arab Rep. in 1979 to that in 1981?
Provide a succinct answer. 0.71. What is the ratio of the % of value added in manufacturing of Bolivia in 1979 to that in 1982?
Offer a very short reply. 1.78. What is the ratio of the % of value added in manufacturing in Egypt, Arab Rep. in 1979 to that in 1982?
Keep it short and to the point. 0.52. What is the ratio of the % of value added in manufacturing in Gambia, The in 1979 to that in 1982?
Make the answer very short. 1.46. What is the ratio of the % of value added in manufacturing of Guatemala in 1979 to that in 1982?
Offer a terse response. 0.92. What is the ratio of the % of value added in manufacturing of Bolivia in 1980 to that in 1981?
Provide a short and direct response. 0.8. What is the ratio of the % of value added in manufacturing of Egypt, Arab Rep. in 1980 to that in 1981?
Keep it short and to the point. 0.71. What is the ratio of the % of value added in manufacturing in Gambia, The in 1980 to that in 1981?
Your answer should be very brief. 1.39. What is the ratio of the % of value added in manufacturing in Guatemala in 1980 to that in 1981?
Your answer should be compact. 1.08. What is the ratio of the % of value added in manufacturing in Bolivia in 1980 to that in 1982?
Offer a terse response. 1.01. What is the ratio of the % of value added in manufacturing in Egypt, Arab Rep. in 1980 to that in 1982?
Offer a very short reply. 0.52. What is the ratio of the % of value added in manufacturing of Gambia, The in 1980 to that in 1982?
Make the answer very short. 2.05. What is the ratio of the % of value added in manufacturing in Guatemala in 1980 to that in 1982?
Offer a very short reply. 1. What is the ratio of the % of value added in manufacturing of Bolivia in 1981 to that in 1982?
Offer a very short reply. 1.26. What is the ratio of the % of value added in manufacturing of Egypt, Arab Rep. in 1981 to that in 1982?
Your answer should be very brief. 0.73. What is the ratio of the % of value added in manufacturing of Gambia, The in 1981 to that in 1982?
Offer a terse response. 1.47. What is the ratio of the % of value added in manufacturing of Guatemala in 1981 to that in 1982?
Give a very brief answer. 0.93. What is the difference between the highest and the second highest % of value added in manufacturing of Bolivia?
Your answer should be compact. 0.1. What is the difference between the highest and the second highest % of value added in manufacturing in Egypt, Arab Rep.?
Offer a very short reply. 4.6. What is the difference between the highest and the second highest % of value added in manufacturing in Gambia, The?
Make the answer very short. 0.5. What is the difference between the highest and the second highest % of value added in manufacturing in Guatemala?
Give a very brief answer. 0.06. What is the difference between the highest and the lowest % of value added in manufacturing of Bolivia?
Keep it short and to the point. 2.42. What is the difference between the highest and the lowest % of value added in manufacturing of Egypt, Arab Rep.?
Ensure brevity in your answer.  8.21. What is the difference between the highest and the lowest % of value added in manufacturing in Gambia, The?
Provide a succinct answer. 3.64. What is the difference between the highest and the lowest % of value added in manufacturing in Guatemala?
Keep it short and to the point. 5.19. 